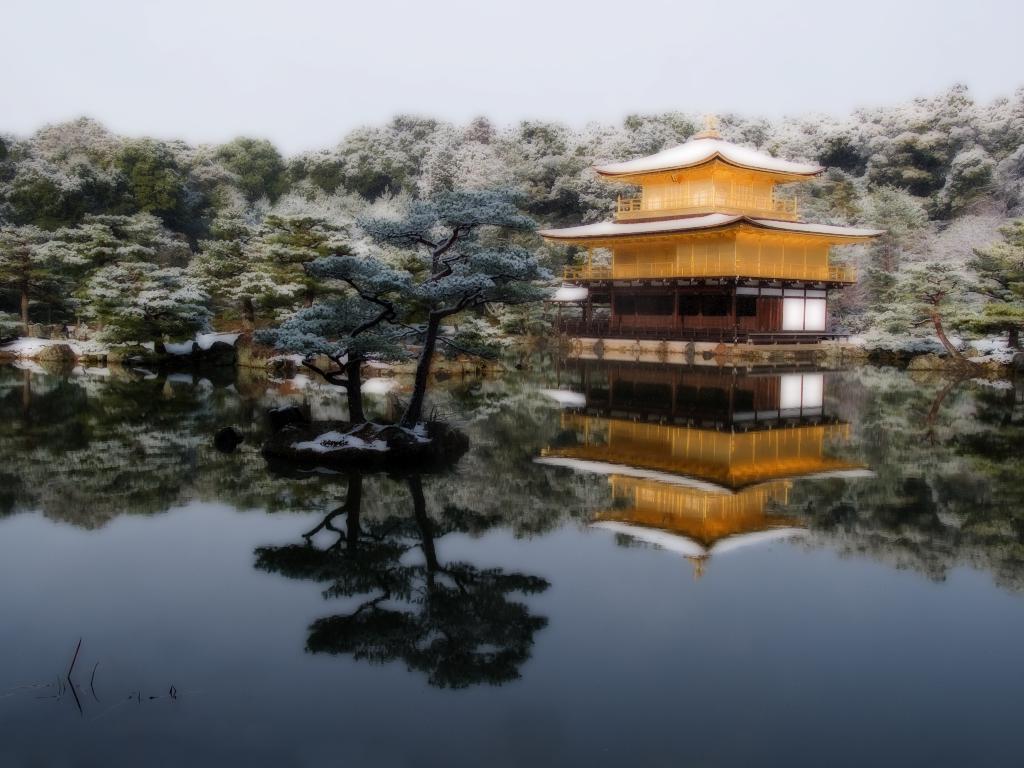How would you summarize this image in a sentence or two? This is an edited image. At the bottom of the image there is water. There are two trees in the water. In the background there is a house and also there are many trees. 